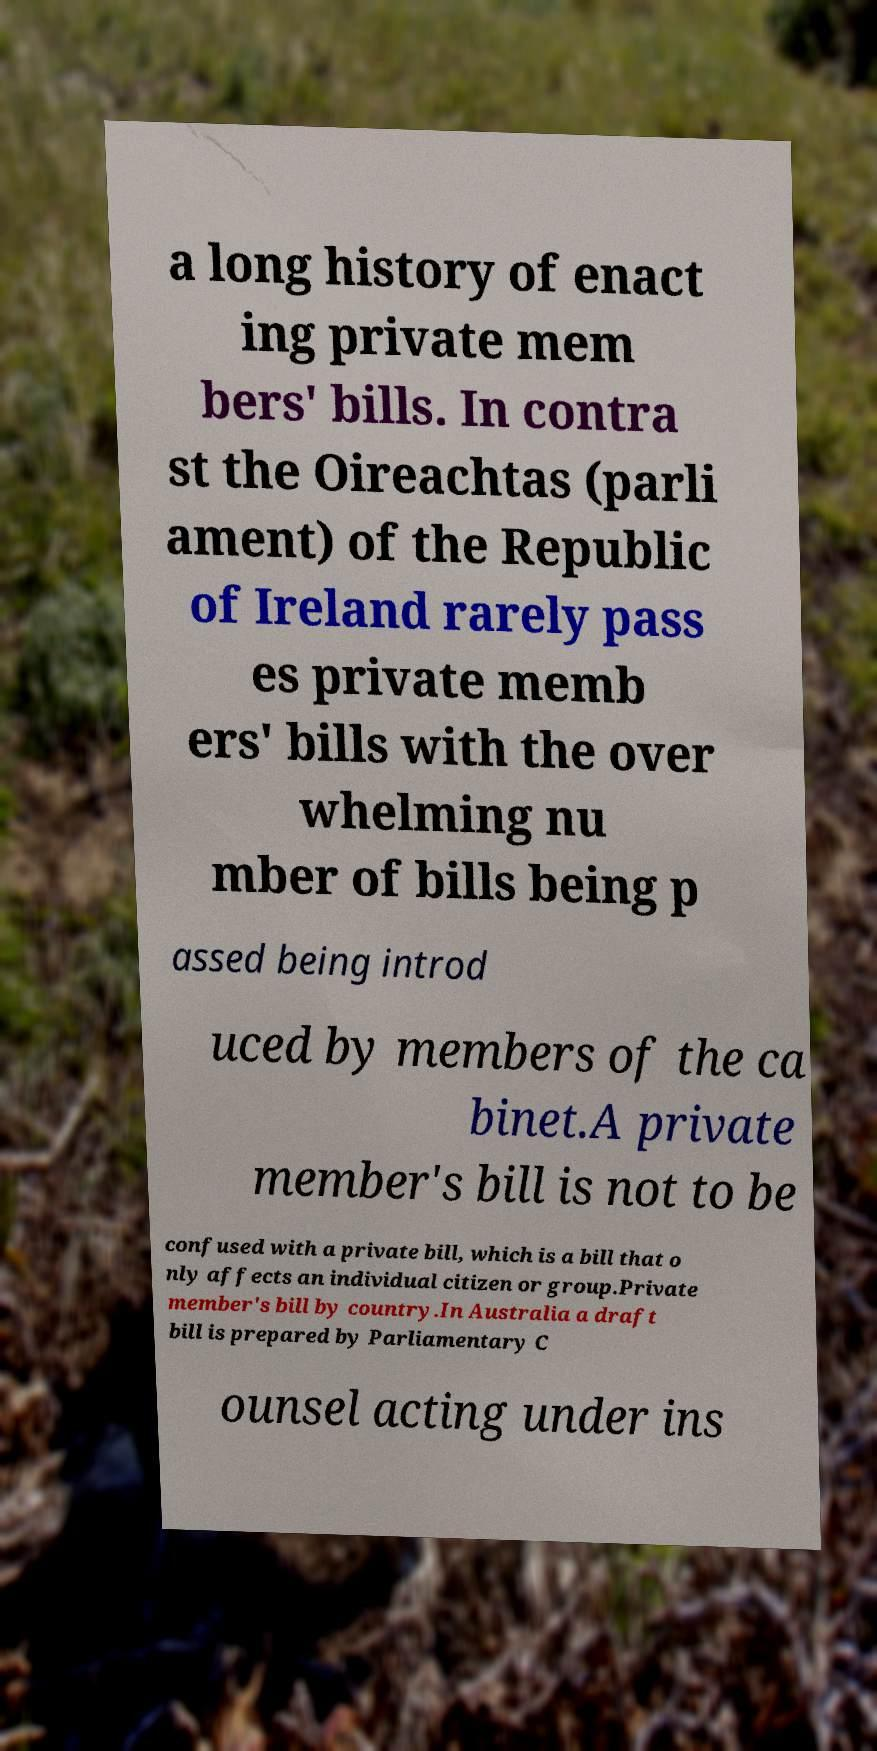There's text embedded in this image that I need extracted. Can you transcribe it verbatim? a long history of enact ing private mem bers' bills. In contra st the Oireachtas (parli ament) of the Republic of Ireland rarely pass es private memb ers' bills with the over whelming nu mber of bills being p assed being introd uced by members of the ca binet.A private member's bill is not to be confused with a private bill, which is a bill that o nly affects an individual citizen or group.Private member's bill by country.In Australia a draft bill is prepared by Parliamentary C ounsel acting under ins 